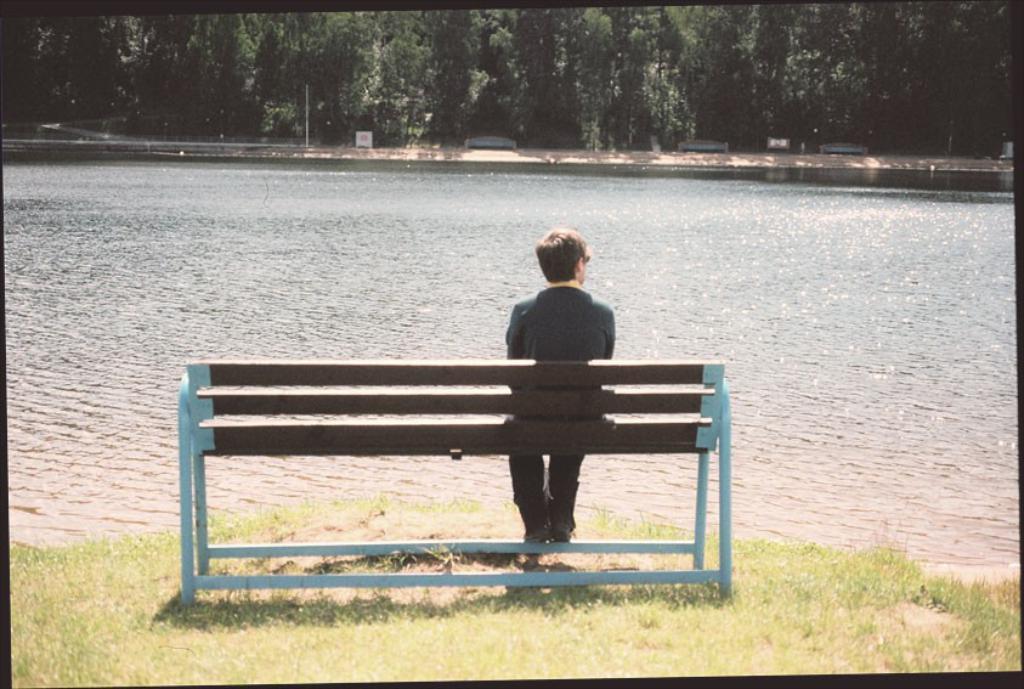Could you give a brief overview of what you see in this image? This man is sitting on a bench. This is a freshwater river. Far there are number of trees. Grass is in green color. 